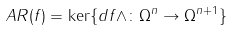<formula> <loc_0><loc_0><loc_500><loc_500>A R ( f ) = \ker \{ d f \wedge \colon \Omega ^ { n } \to \Omega ^ { n + 1 } \}</formula> 